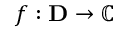<formula> <loc_0><loc_0><loc_500><loc_500>f \colon D \rightarrow \mathbb { C }</formula> 